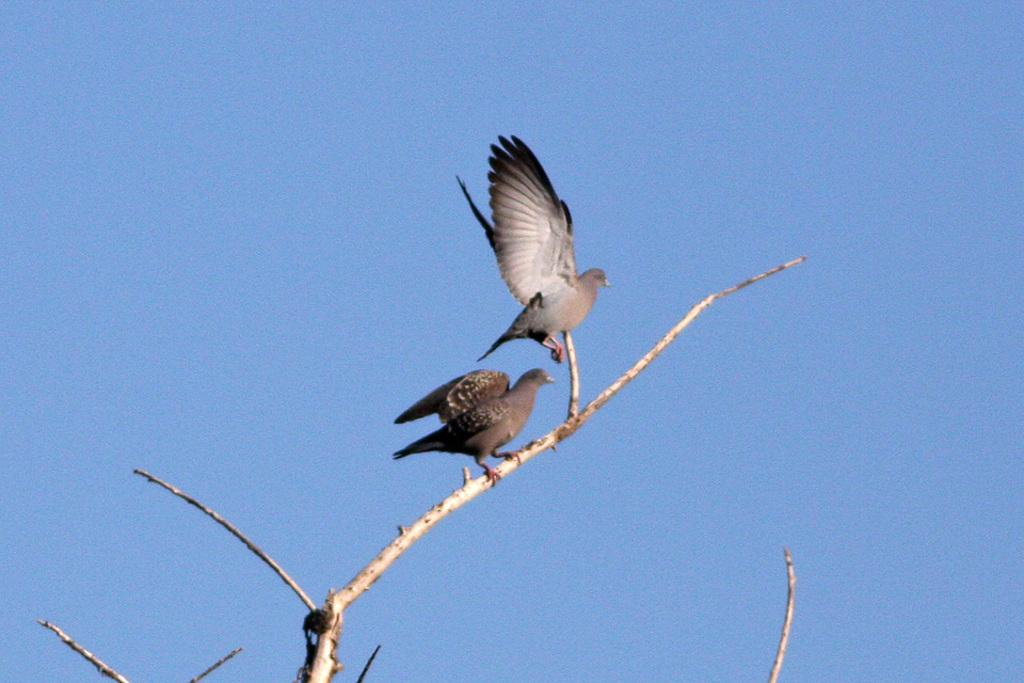How many birds are present in the image? There are two birds in the image. Where are the birds located? The birds are on a dry branch. What colors are the birds? The birds are in grey and white color. What is the color of the sky in the image? The sky is blue in the image. How many mountains can be seen in the image? There are no mountains present in the image. What type of tooth is visible in the image? There is no tooth visible in the image. 